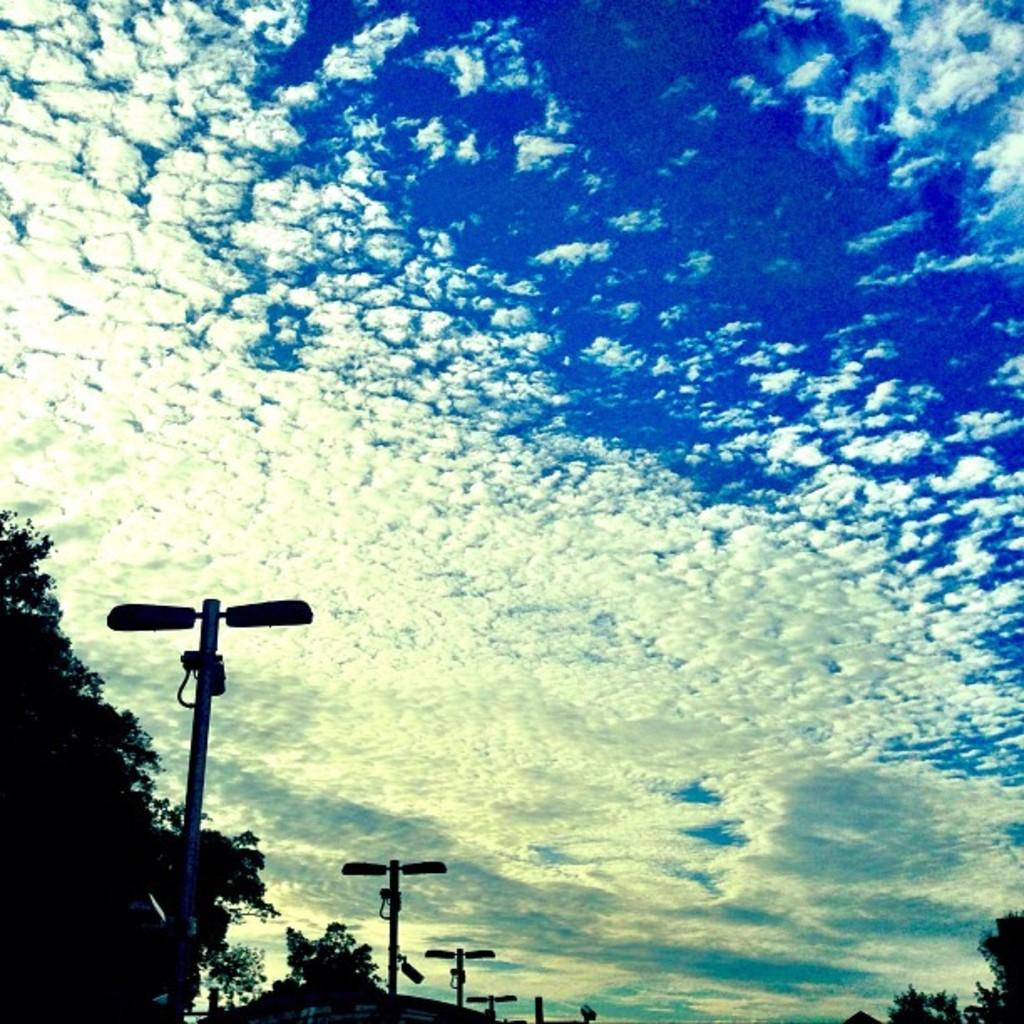Where was the image taken? The image was clicked outside. What can be seen in the foreground of the image? There are street lights, poles, and trees in the foreground. What is visible in the background of the image? The sky is visible in the background. How would you describe the sky in the image? The sky is full of clouds. What type of cover is being used on the stage in the image? There is no stage or cover present in the image; it features an outdoor scene with street lights, poles, trees, and a cloudy sky. How many wheels can be seen on the objects in the image? There are no wheels visible in the image. 